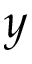<formula> <loc_0><loc_0><loc_500><loc_500>y</formula> 